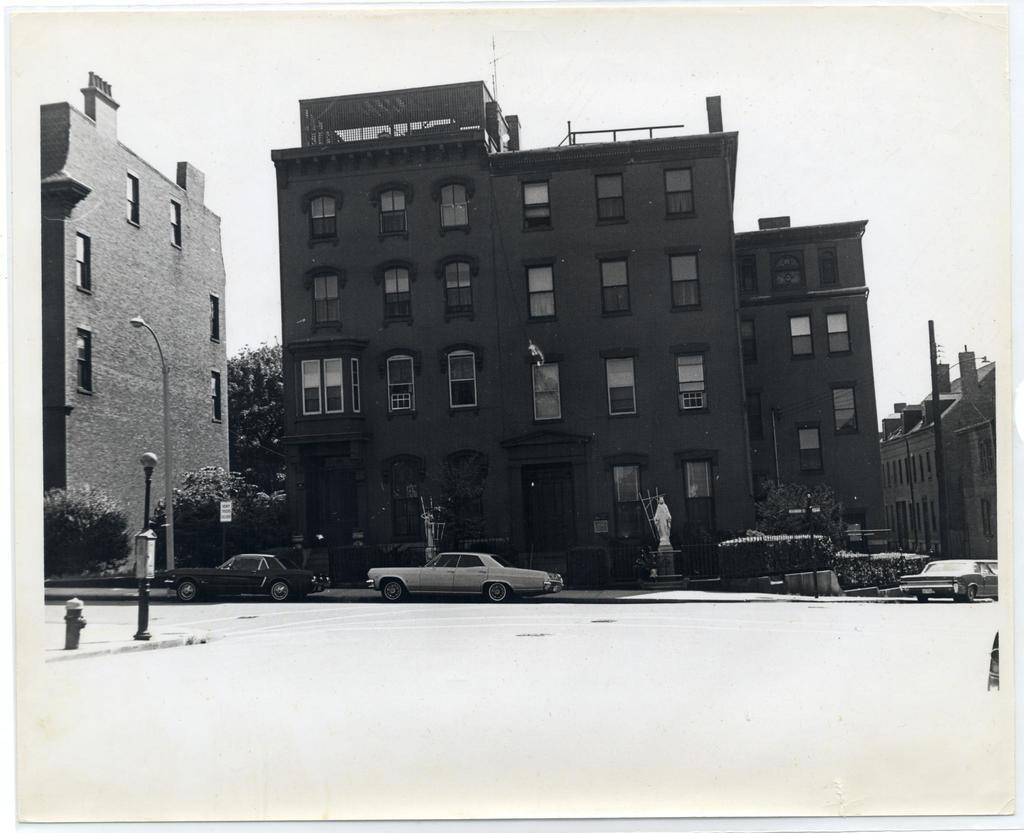What can be seen on the road in the image? There are vehicles on the road in the image. What type of structures are visible in the image? There are buildings in the image. What are the light poles used for in the image? The light poles are present in the image to provide illumination. What type of vegetation is present in the image? There is a tree and plants visible in the image. What is the statue in the image depicting? The statue is visible in the image, but its subject or meaning is not clear from the provided facts. What is visible in the background of the image? The sky is visible in the background of the image. What type of canvas is being used by the behavior in the image? There is no canvas or behavior present in the image. What act is the statue performing in the image? The statue is visible in the image, but its subject or actions are not clear from the provided facts. 